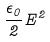Convert formula to latex. <formula><loc_0><loc_0><loc_500><loc_500>\frac { \epsilon _ { 0 } } { 2 } E ^ { 2 }</formula> 